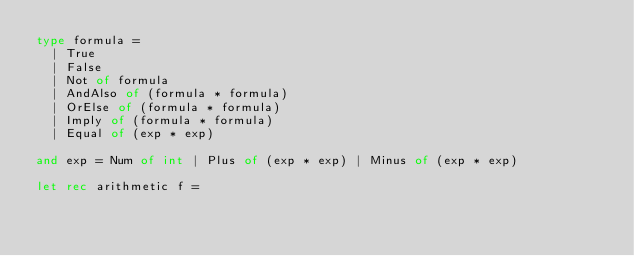<code> <loc_0><loc_0><loc_500><loc_500><_OCaml_>type formula =
  | True
  | False
  | Not of formula
  | AndAlso of (formula * formula)
  | OrElse of (formula * formula)
  | Imply of (formula * formula)
  | Equal of (exp * exp)

and exp = Num of int | Plus of (exp * exp) | Minus of (exp * exp)

let rec arithmetic f =</code> 